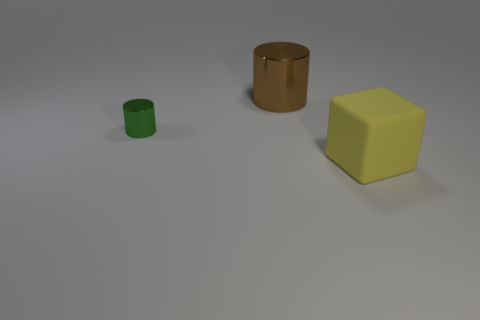Add 1 big blue things. How many objects exist? 4 Subtract all cylinders. How many objects are left? 1 Add 2 gray blocks. How many gray blocks exist? 2 Subtract 0 brown spheres. How many objects are left? 3 Subtract all brown shiny objects. Subtract all big brown things. How many objects are left? 1 Add 1 big yellow blocks. How many big yellow blocks are left? 2 